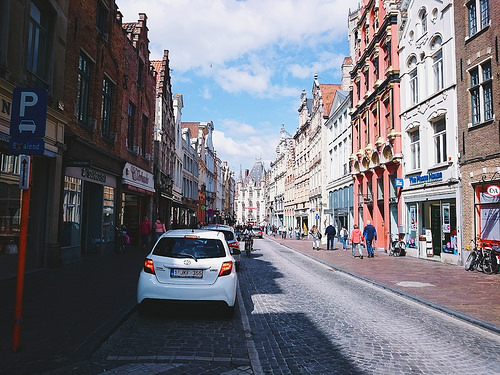<image>
Is the car next to the road? Yes. The car is positioned adjacent to the road, located nearby in the same general area. Where is the car in relation to the sidewalk? Is it next to the sidewalk? Yes. The car is positioned adjacent to the sidewalk, located nearby in the same general area. Where is the people in relation to the car? Is it in front of the car? Yes. The people is positioned in front of the car, appearing closer to the camera viewpoint. Where is the car in relation to the shop? Is it in front of the shop? Yes. The car is positioned in front of the shop, appearing closer to the camera viewpoint. 